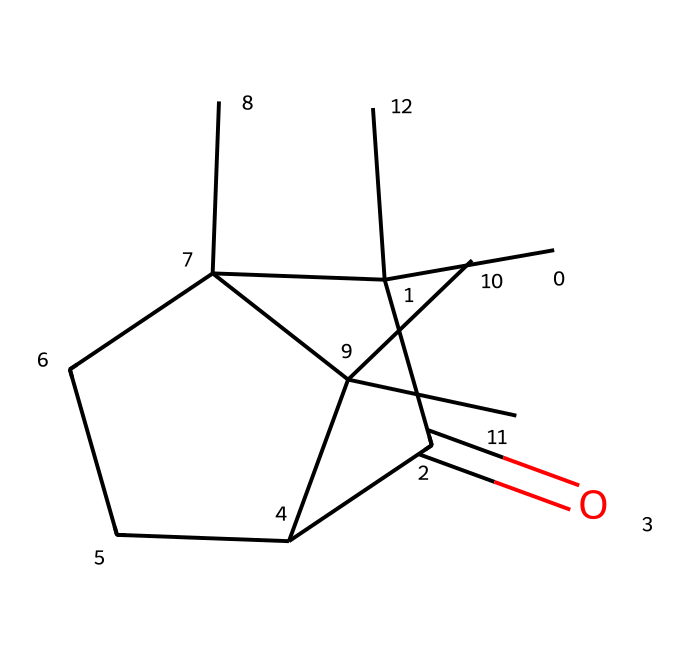What is the primary functional group in camphor? The SMILES representation indicates a ketone functional group due to the presence of the carbonyl group (C=O) attached to a carbon atom.
Answer: ketone How many carbon atoms are present in camphor? By analyzing the SMILES, there are a total of 10 carbon atoms (including all distinct carbon sites in the structure).
Answer: 10 What is the total number of hydrogen atoms in camphor? Each carbon typically makes four bonds and in this structure, taking into account the valences and the presence of the carbonyl, there are 16 hydrogen atoms bonded to the carbon framework.
Answer: 16 Is camphor a solid or a liquid at room temperature? Camphor has a low melting point of around 175°C and is known to be solid at room temperature.
Answer: solid What type of organic compound is camphor? The structure reveals that camphor has a ketone functional group, categorizing it as a type of ketone, a common type of organic compound.
Answer: ketone How many rings are present in the structure of camphor? The SMILES indicates two ring structures in the chemical layout, which can be observed in the cyclic parts of the structure.
Answer: 2 Does camphor have any isomers? Yes, camphor can have stereoisomers due to the presence of chiral centers in its structure, specifically at the carbon atoms that are bonded to four different substituents.
Answer: yes 